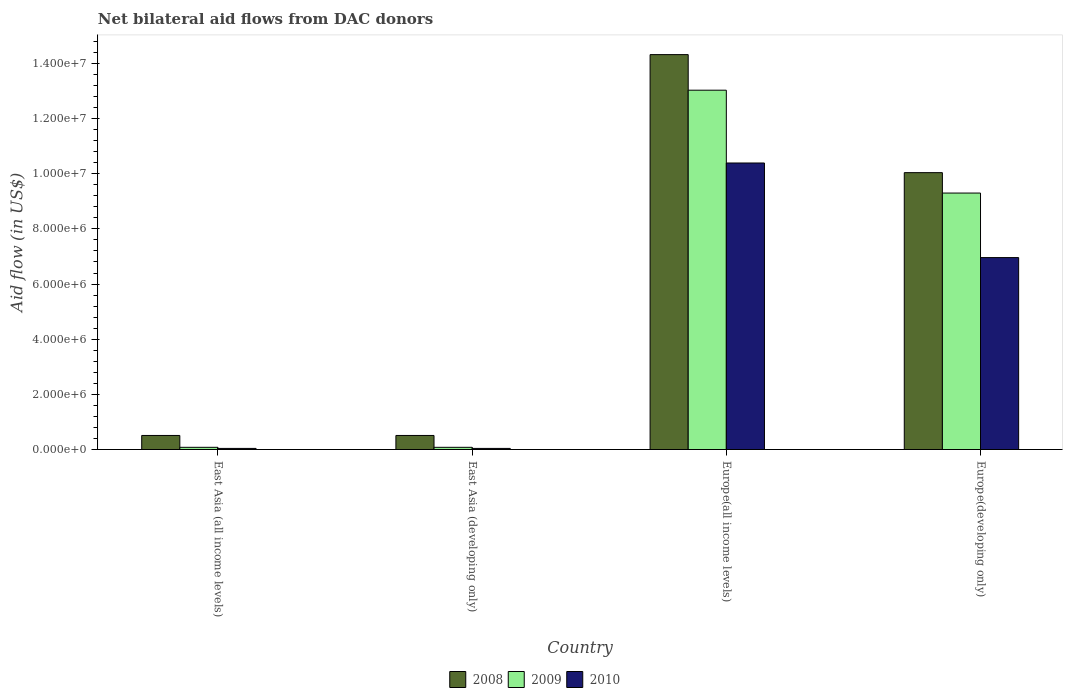How many different coloured bars are there?
Your answer should be very brief. 3. Are the number of bars per tick equal to the number of legend labels?
Your response must be concise. Yes. How many bars are there on the 4th tick from the left?
Your answer should be compact. 3. What is the label of the 1st group of bars from the left?
Provide a short and direct response. East Asia (all income levels). Across all countries, what is the maximum net bilateral aid flow in 2008?
Provide a short and direct response. 1.43e+07. In which country was the net bilateral aid flow in 2009 maximum?
Provide a succinct answer. Europe(all income levels). In which country was the net bilateral aid flow in 2008 minimum?
Provide a succinct answer. East Asia (all income levels). What is the total net bilateral aid flow in 2009 in the graph?
Provide a succinct answer. 2.25e+07. What is the difference between the net bilateral aid flow in 2008 in East Asia (all income levels) and that in East Asia (developing only)?
Your answer should be compact. 0. What is the difference between the net bilateral aid flow in 2008 in Europe(all income levels) and the net bilateral aid flow in 2010 in East Asia (developing only)?
Provide a succinct answer. 1.43e+07. What is the average net bilateral aid flow in 2009 per country?
Give a very brief answer. 5.62e+06. What is the difference between the net bilateral aid flow of/in 2009 and net bilateral aid flow of/in 2010 in East Asia (all income levels)?
Your answer should be compact. 4.00e+04. In how many countries, is the net bilateral aid flow in 2008 greater than 11600000 US$?
Your answer should be compact. 1. What is the difference between the highest and the second highest net bilateral aid flow in 2009?
Your answer should be compact. 3.73e+06. What is the difference between the highest and the lowest net bilateral aid flow in 2008?
Keep it short and to the point. 1.38e+07. Is the sum of the net bilateral aid flow in 2009 in East Asia (developing only) and Europe(all income levels) greater than the maximum net bilateral aid flow in 2010 across all countries?
Your answer should be compact. Yes. What does the 2nd bar from the left in East Asia (developing only) represents?
Offer a terse response. 2009. How many bars are there?
Ensure brevity in your answer.  12. Are all the bars in the graph horizontal?
Ensure brevity in your answer.  No. What is the difference between two consecutive major ticks on the Y-axis?
Give a very brief answer. 2.00e+06. Does the graph contain any zero values?
Offer a very short reply. No. Does the graph contain grids?
Keep it short and to the point. No. Where does the legend appear in the graph?
Your response must be concise. Bottom center. What is the title of the graph?
Offer a terse response. Net bilateral aid flows from DAC donors. What is the label or title of the X-axis?
Your answer should be very brief. Country. What is the label or title of the Y-axis?
Ensure brevity in your answer.  Aid flow (in US$). What is the Aid flow (in US$) of 2008 in East Asia (all income levels)?
Your answer should be very brief. 5.10e+05. What is the Aid flow (in US$) of 2010 in East Asia (all income levels)?
Offer a terse response. 4.00e+04. What is the Aid flow (in US$) of 2008 in East Asia (developing only)?
Provide a short and direct response. 5.10e+05. What is the Aid flow (in US$) in 2009 in East Asia (developing only)?
Your answer should be compact. 8.00e+04. What is the Aid flow (in US$) in 2010 in East Asia (developing only)?
Give a very brief answer. 4.00e+04. What is the Aid flow (in US$) in 2008 in Europe(all income levels)?
Offer a very short reply. 1.43e+07. What is the Aid flow (in US$) in 2009 in Europe(all income levels)?
Your answer should be compact. 1.30e+07. What is the Aid flow (in US$) in 2010 in Europe(all income levels)?
Ensure brevity in your answer.  1.04e+07. What is the Aid flow (in US$) of 2008 in Europe(developing only)?
Your answer should be very brief. 1.00e+07. What is the Aid flow (in US$) of 2009 in Europe(developing only)?
Your answer should be compact. 9.30e+06. What is the Aid flow (in US$) in 2010 in Europe(developing only)?
Offer a very short reply. 6.96e+06. Across all countries, what is the maximum Aid flow (in US$) of 2008?
Give a very brief answer. 1.43e+07. Across all countries, what is the maximum Aid flow (in US$) of 2009?
Your answer should be compact. 1.30e+07. Across all countries, what is the maximum Aid flow (in US$) of 2010?
Your answer should be compact. 1.04e+07. Across all countries, what is the minimum Aid flow (in US$) in 2008?
Give a very brief answer. 5.10e+05. Across all countries, what is the minimum Aid flow (in US$) in 2010?
Your answer should be very brief. 4.00e+04. What is the total Aid flow (in US$) in 2008 in the graph?
Keep it short and to the point. 2.54e+07. What is the total Aid flow (in US$) of 2009 in the graph?
Your response must be concise. 2.25e+07. What is the total Aid flow (in US$) of 2010 in the graph?
Give a very brief answer. 1.74e+07. What is the difference between the Aid flow (in US$) of 2008 in East Asia (all income levels) and that in East Asia (developing only)?
Your response must be concise. 0. What is the difference between the Aid flow (in US$) of 2010 in East Asia (all income levels) and that in East Asia (developing only)?
Give a very brief answer. 0. What is the difference between the Aid flow (in US$) in 2008 in East Asia (all income levels) and that in Europe(all income levels)?
Your answer should be very brief. -1.38e+07. What is the difference between the Aid flow (in US$) of 2009 in East Asia (all income levels) and that in Europe(all income levels)?
Give a very brief answer. -1.30e+07. What is the difference between the Aid flow (in US$) in 2010 in East Asia (all income levels) and that in Europe(all income levels)?
Offer a terse response. -1.04e+07. What is the difference between the Aid flow (in US$) of 2008 in East Asia (all income levels) and that in Europe(developing only)?
Ensure brevity in your answer.  -9.53e+06. What is the difference between the Aid flow (in US$) in 2009 in East Asia (all income levels) and that in Europe(developing only)?
Your answer should be very brief. -9.22e+06. What is the difference between the Aid flow (in US$) of 2010 in East Asia (all income levels) and that in Europe(developing only)?
Keep it short and to the point. -6.92e+06. What is the difference between the Aid flow (in US$) of 2008 in East Asia (developing only) and that in Europe(all income levels)?
Offer a terse response. -1.38e+07. What is the difference between the Aid flow (in US$) in 2009 in East Asia (developing only) and that in Europe(all income levels)?
Ensure brevity in your answer.  -1.30e+07. What is the difference between the Aid flow (in US$) in 2010 in East Asia (developing only) and that in Europe(all income levels)?
Offer a very short reply. -1.04e+07. What is the difference between the Aid flow (in US$) of 2008 in East Asia (developing only) and that in Europe(developing only)?
Make the answer very short. -9.53e+06. What is the difference between the Aid flow (in US$) of 2009 in East Asia (developing only) and that in Europe(developing only)?
Give a very brief answer. -9.22e+06. What is the difference between the Aid flow (in US$) of 2010 in East Asia (developing only) and that in Europe(developing only)?
Your answer should be compact. -6.92e+06. What is the difference between the Aid flow (in US$) in 2008 in Europe(all income levels) and that in Europe(developing only)?
Keep it short and to the point. 4.28e+06. What is the difference between the Aid flow (in US$) of 2009 in Europe(all income levels) and that in Europe(developing only)?
Provide a succinct answer. 3.73e+06. What is the difference between the Aid flow (in US$) in 2010 in Europe(all income levels) and that in Europe(developing only)?
Ensure brevity in your answer.  3.43e+06. What is the difference between the Aid flow (in US$) of 2008 in East Asia (all income levels) and the Aid flow (in US$) of 2010 in East Asia (developing only)?
Provide a succinct answer. 4.70e+05. What is the difference between the Aid flow (in US$) of 2008 in East Asia (all income levels) and the Aid flow (in US$) of 2009 in Europe(all income levels)?
Your answer should be compact. -1.25e+07. What is the difference between the Aid flow (in US$) in 2008 in East Asia (all income levels) and the Aid flow (in US$) in 2010 in Europe(all income levels)?
Your response must be concise. -9.88e+06. What is the difference between the Aid flow (in US$) of 2009 in East Asia (all income levels) and the Aid flow (in US$) of 2010 in Europe(all income levels)?
Your answer should be compact. -1.03e+07. What is the difference between the Aid flow (in US$) in 2008 in East Asia (all income levels) and the Aid flow (in US$) in 2009 in Europe(developing only)?
Your answer should be compact. -8.79e+06. What is the difference between the Aid flow (in US$) of 2008 in East Asia (all income levels) and the Aid flow (in US$) of 2010 in Europe(developing only)?
Ensure brevity in your answer.  -6.45e+06. What is the difference between the Aid flow (in US$) in 2009 in East Asia (all income levels) and the Aid flow (in US$) in 2010 in Europe(developing only)?
Give a very brief answer. -6.88e+06. What is the difference between the Aid flow (in US$) of 2008 in East Asia (developing only) and the Aid flow (in US$) of 2009 in Europe(all income levels)?
Your answer should be compact. -1.25e+07. What is the difference between the Aid flow (in US$) in 2008 in East Asia (developing only) and the Aid flow (in US$) in 2010 in Europe(all income levels)?
Your answer should be compact. -9.88e+06. What is the difference between the Aid flow (in US$) of 2009 in East Asia (developing only) and the Aid flow (in US$) of 2010 in Europe(all income levels)?
Keep it short and to the point. -1.03e+07. What is the difference between the Aid flow (in US$) in 2008 in East Asia (developing only) and the Aid flow (in US$) in 2009 in Europe(developing only)?
Ensure brevity in your answer.  -8.79e+06. What is the difference between the Aid flow (in US$) in 2008 in East Asia (developing only) and the Aid flow (in US$) in 2010 in Europe(developing only)?
Give a very brief answer. -6.45e+06. What is the difference between the Aid flow (in US$) of 2009 in East Asia (developing only) and the Aid flow (in US$) of 2010 in Europe(developing only)?
Provide a succinct answer. -6.88e+06. What is the difference between the Aid flow (in US$) of 2008 in Europe(all income levels) and the Aid flow (in US$) of 2009 in Europe(developing only)?
Provide a short and direct response. 5.02e+06. What is the difference between the Aid flow (in US$) of 2008 in Europe(all income levels) and the Aid flow (in US$) of 2010 in Europe(developing only)?
Provide a succinct answer. 7.36e+06. What is the difference between the Aid flow (in US$) of 2009 in Europe(all income levels) and the Aid flow (in US$) of 2010 in Europe(developing only)?
Keep it short and to the point. 6.07e+06. What is the average Aid flow (in US$) in 2008 per country?
Give a very brief answer. 6.34e+06. What is the average Aid flow (in US$) of 2009 per country?
Your response must be concise. 5.62e+06. What is the average Aid flow (in US$) of 2010 per country?
Provide a succinct answer. 4.36e+06. What is the difference between the Aid flow (in US$) of 2008 and Aid flow (in US$) of 2010 in East Asia (all income levels)?
Offer a terse response. 4.70e+05. What is the difference between the Aid flow (in US$) of 2009 and Aid flow (in US$) of 2010 in East Asia (all income levels)?
Provide a succinct answer. 4.00e+04. What is the difference between the Aid flow (in US$) in 2008 and Aid flow (in US$) in 2009 in Europe(all income levels)?
Provide a succinct answer. 1.29e+06. What is the difference between the Aid flow (in US$) of 2008 and Aid flow (in US$) of 2010 in Europe(all income levels)?
Your answer should be very brief. 3.93e+06. What is the difference between the Aid flow (in US$) of 2009 and Aid flow (in US$) of 2010 in Europe(all income levels)?
Your response must be concise. 2.64e+06. What is the difference between the Aid flow (in US$) in 2008 and Aid flow (in US$) in 2009 in Europe(developing only)?
Offer a terse response. 7.40e+05. What is the difference between the Aid flow (in US$) of 2008 and Aid flow (in US$) of 2010 in Europe(developing only)?
Make the answer very short. 3.08e+06. What is the difference between the Aid flow (in US$) of 2009 and Aid flow (in US$) of 2010 in Europe(developing only)?
Provide a succinct answer. 2.34e+06. What is the ratio of the Aid flow (in US$) of 2008 in East Asia (all income levels) to that in East Asia (developing only)?
Your response must be concise. 1. What is the ratio of the Aid flow (in US$) in 2009 in East Asia (all income levels) to that in East Asia (developing only)?
Ensure brevity in your answer.  1. What is the ratio of the Aid flow (in US$) in 2010 in East Asia (all income levels) to that in East Asia (developing only)?
Provide a succinct answer. 1. What is the ratio of the Aid flow (in US$) in 2008 in East Asia (all income levels) to that in Europe(all income levels)?
Your response must be concise. 0.04. What is the ratio of the Aid flow (in US$) in 2009 in East Asia (all income levels) to that in Europe(all income levels)?
Ensure brevity in your answer.  0.01. What is the ratio of the Aid flow (in US$) in 2010 in East Asia (all income levels) to that in Europe(all income levels)?
Offer a terse response. 0. What is the ratio of the Aid flow (in US$) of 2008 in East Asia (all income levels) to that in Europe(developing only)?
Keep it short and to the point. 0.05. What is the ratio of the Aid flow (in US$) in 2009 in East Asia (all income levels) to that in Europe(developing only)?
Your answer should be very brief. 0.01. What is the ratio of the Aid flow (in US$) of 2010 in East Asia (all income levels) to that in Europe(developing only)?
Provide a succinct answer. 0.01. What is the ratio of the Aid flow (in US$) of 2008 in East Asia (developing only) to that in Europe(all income levels)?
Offer a very short reply. 0.04. What is the ratio of the Aid flow (in US$) of 2009 in East Asia (developing only) to that in Europe(all income levels)?
Offer a terse response. 0.01. What is the ratio of the Aid flow (in US$) of 2010 in East Asia (developing only) to that in Europe(all income levels)?
Provide a short and direct response. 0. What is the ratio of the Aid flow (in US$) in 2008 in East Asia (developing only) to that in Europe(developing only)?
Give a very brief answer. 0.05. What is the ratio of the Aid flow (in US$) in 2009 in East Asia (developing only) to that in Europe(developing only)?
Make the answer very short. 0.01. What is the ratio of the Aid flow (in US$) in 2010 in East Asia (developing only) to that in Europe(developing only)?
Offer a terse response. 0.01. What is the ratio of the Aid flow (in US$) in 2008 in Europe(all income levels) to that in Europe(developing only)?
Keep it short and to the point. 1.43. What is the ratio of the Aid flow (in US$) of 2009 in Europe(all income levels) to that in Europe(developing only)?
Your answer should be very brief. 1.4. What is the ratio of the Aid flow (in US$) of 2010 in Europe(all income levels) to that in Europe(developing only)?
Ensure brevity in your answer.  1.49. What is the difference between the highest and the second highest Aid flow (in US$) of 2008?
Offer a very short reply. 4.28e+06. What is the difference between the highest and the second highest Aid flow (in US$) of 2009?
Your answer should be very brief. 3.73e+06. What is the difference between the highest and the second highest Aid flow (in US$) of 2010?
Provide a succinct answer. 3.43e+06. What is the difference between the highest and the lowest Aid flow (in US$) of 2008?
Offer a terse response. 1.38e+07. What is the difference between the highest and the lowest Aid flow (in US$) of 2009?
Your answer should be compact. 1.30e+07. What is the difference between the highest and the lowest Aid flow (in US$) in 2010?
Ensure brevity in your answer.  1.04e+07. 